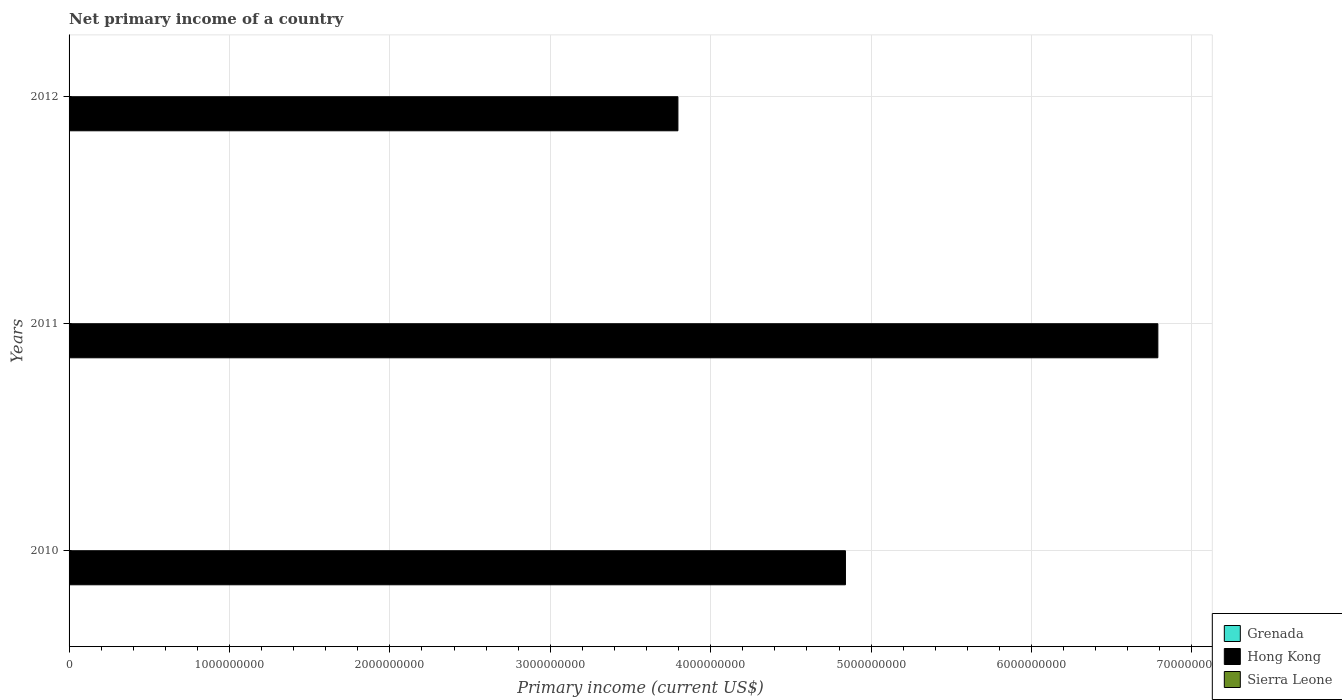How many bars are there on the 3rd tick from the bottom?
Offer a very short reply. 1. Across all years, what is the maximum primary income in Hong Kong?
Make the answer very short. 6.79e+09. What is the difference between the primary income in Hong Kong in 2011 and that in 2012?
Ensure brevity in your answer.  2.99e+09. In how many years, is the primary income in Sierra Leone greater than 4400000000 US$?
Offer a terse response. 0. What is the ratio of the primary income in Hong Kong in 2010 to that in 2012?
Your answer should be compact. 1.28. What is the difference between the highest and the second highest primary income in Hong Kong?
Ensure brevity in your answer.  1.95e+09. Is it the case that in every year, the sum of the primary income in Grenada and primary income in Sierra Leone is greater than the primary income in Hong Kong?
Ensure brevity in your answer.  No. Are all the bars in the graph horizontal?
Ensure brevity in your answer.  Yes. Does the graph contain grids?
Your answer should be very brief. Yes. How many legend labels are there?
Give a very brief answer. 3. How are the legend labels stacked?
Your response must be concise. Vertical. What is the title of the graph?
Keep it short and to the point. Net primary income of a country. What is the label or title of the X-axis?
Your response must be concise. Primary income (current US$). What is the label or title of the Y-axis?
Provide a succinct answer. Years. What is the Primary income (current US$) in Hong Kong in 2010?
Give a very brief answer. 4.84e+09. What is the Primary income (current US$) in Hong Kong in 2011?
Give a very brief answer. 6.79e+09. What is the Primary income (current US$) of Sierra Leone in 2011?
Keep it short and to the point. 0. What is the Primary income (current US$) in Hong Kong in 2012?
Offer a terse response. 3.80e+09. Across all years, what is the maximum Primary income (current US$) of Hong Kong?
Make the answer very short. 6.79e+09. Across all years, what is the minimum Primary income (current US$) in Hong Kong?
Make the answer very short. 3.80e+09. What is the total Primary income (current US$) in Grenada in the graph?
Offer a very short reply. 0. What is the total Primary income (current US$) in Hong Kong in the graph?
Keep it short and to the point. 1.54e+1. What is the difference between the Primary income (current US$) of Hong Kong in 2010 and that in 2011?
Keep it short and to the point. -1.95e+09. What is the difference between the Primary income (current US$) in Hong Kong in 2010 and that in 2012?
Offer a very short reply. 1.04e+09. What is the difference between the Primary income (current US$) in Hong Kong in 2011 and that in 2012?
Offer a terse response. 2.99e+09. What is the average Primary income (current US$) in Hong Kong per year?
Offer a terse response. 5.14e+09. What is the ratio of the Primary income (current US$) in Hong Kong in 2010 to that in 2011?
Offer a terse response. 0.71. What is the ratio of the Primary income (current US$) of Hong Kong in 2010 to that in 2012?
Your answer should be very brief. 1.28. What is the ratio of the Primary income (current US$) in Hong Kong in 2011 to that in 2012?
Your response must be concise. 1.79. What is the difference between the highest and the second highest Primary income (current US$) of Hong Kong?
Offer a terse response. 1.95e+09. What is the difference between the highest and the lowest Primary income (current US$) in Hong Kong?
Keep it short and to the point. 2.99e+09. 